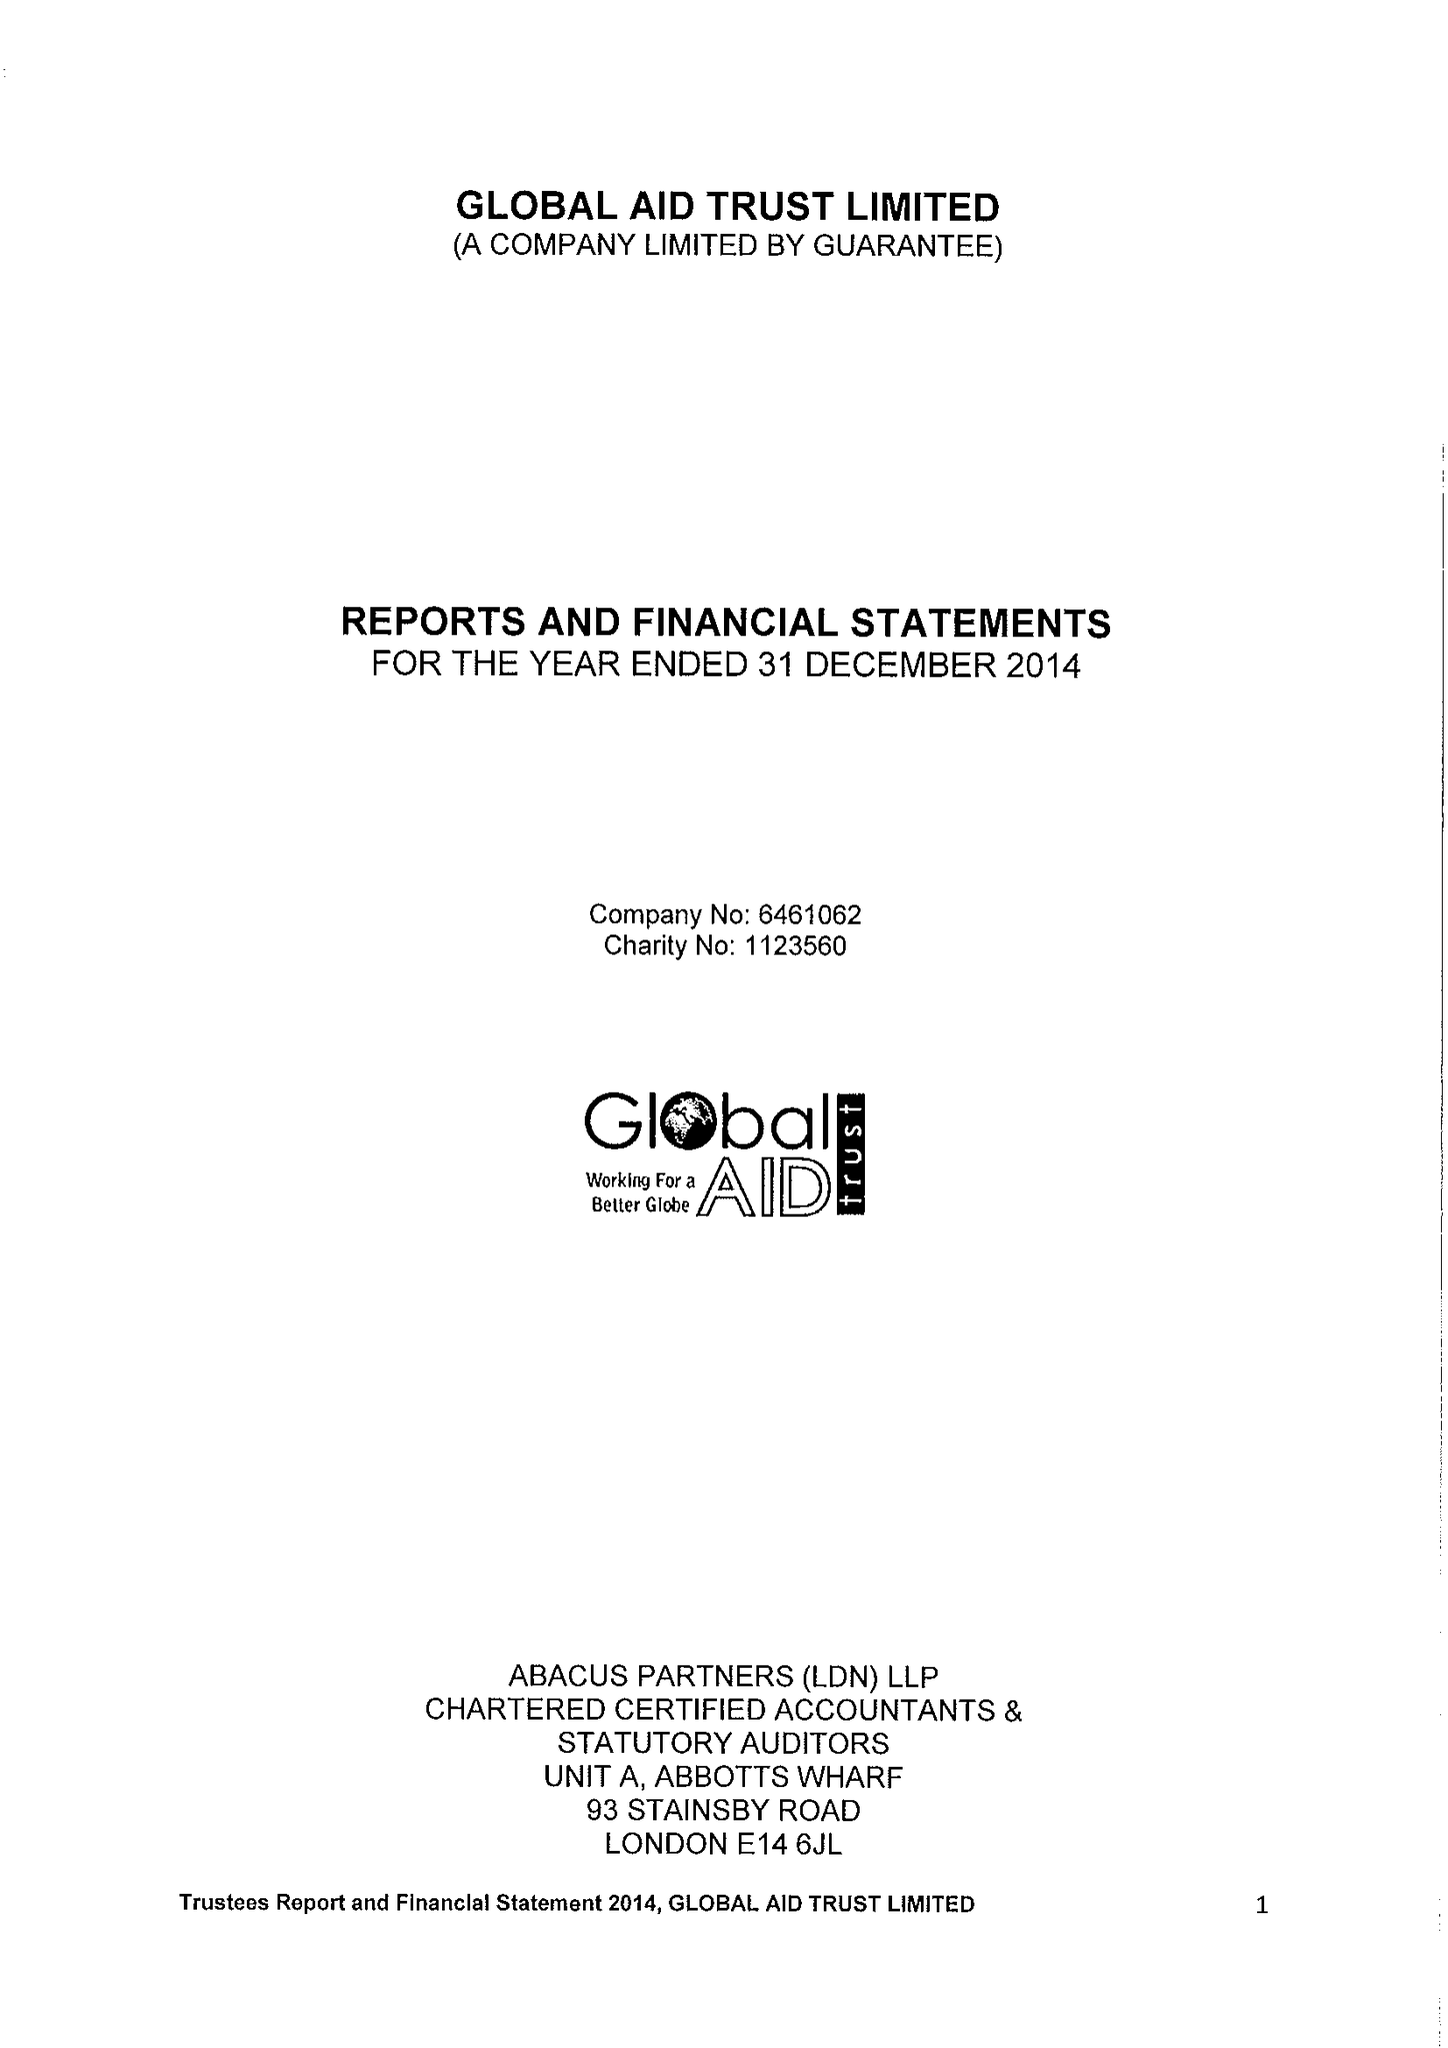What is the value for the address__postcode?
Answer the question using a single word or phrase. E1 2BJ 